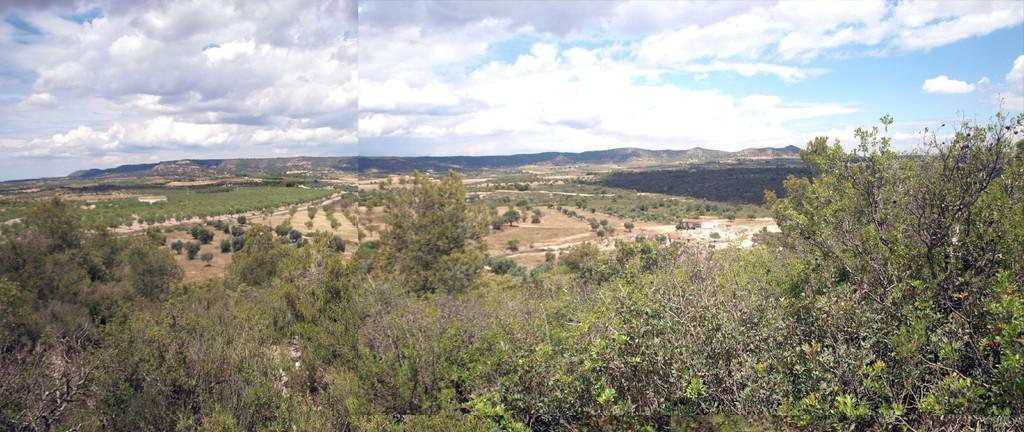What type of artwork is the image? The image is a collage. What can be seen in the sky in the image? There are clouds in the sky in the image. What type of vegetation is present in the image? There is thicket and trees in the image. What part of the natural environment is visible in the image? The ground is visible in the image. What type of noise can be heard coming from the scarecrow in the image? There is no scarecrow present in the image, so it is not possible to determine what noise might be heard. What brand of toothpaste is visible in the image? There is no toothpaste present in the image. 